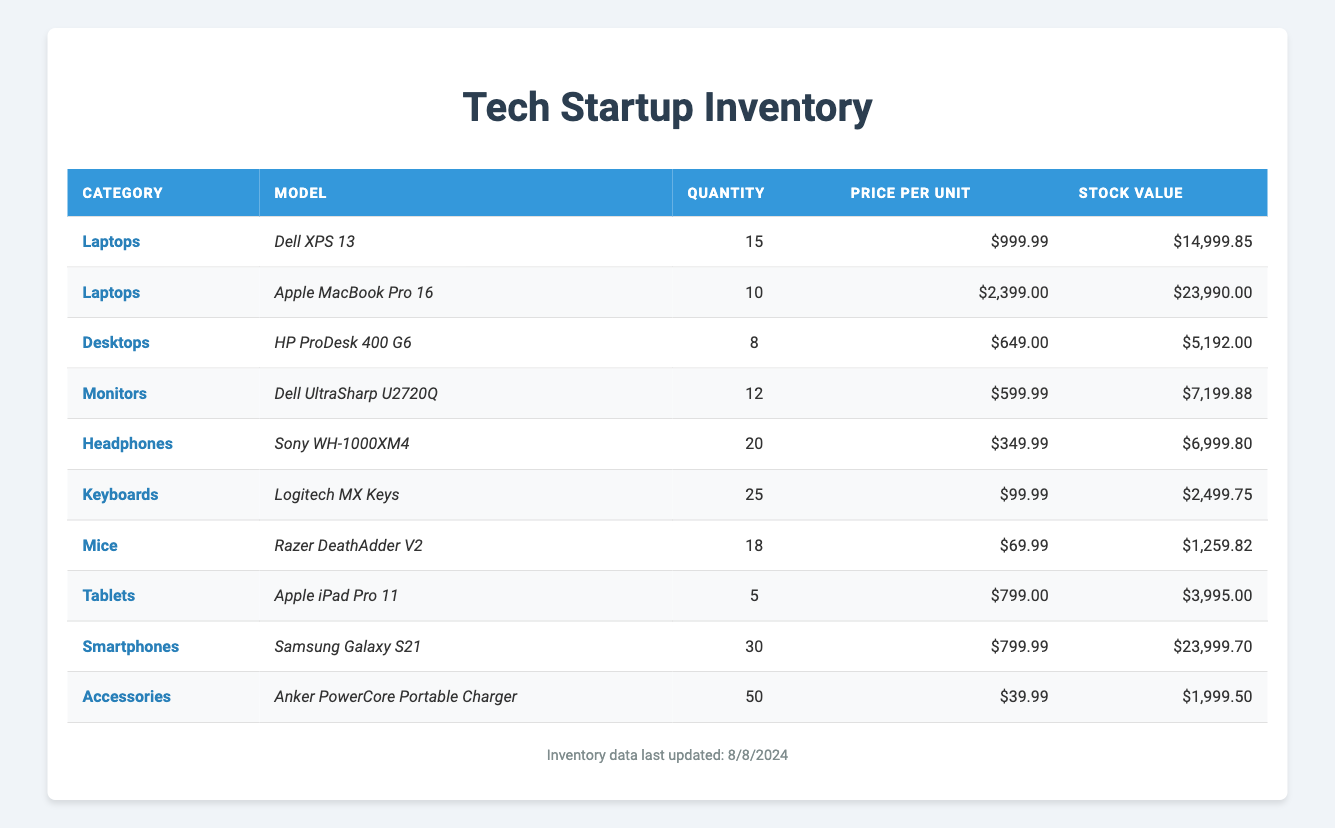What is the total quantity of Laptops in stock? The inventory lists two models of Laptops: Dell XPS 13 with a quantity of 15 and Apple MacBook Pro 16 with a quantity of 10. Adding these quantities together gives 15 + 10 = 25.
Answer: 25 Which model has the highest stock value? The stock values for each model are: Dell XPS 13 - 14999.85, Apple MacBook Pro 16 - 23990.00, HP ProDesk 400 G6 - 5192.00, Dell UltraSharp U2720Q - 7199.88, Sony WH-1000XM4 - 6999.80, Logitech MX Keys - 2499.75, Razer DeathAdder V2 - 1259.82, Apple iPad Pro 11 - 3995.00, Samsung Galaxy S21 - 23999.70, Anker PowerCore Portable Charger - 1999.50. The highest amount is 23990.00 for Apple MacBook Pro 16.
Answer: Apple MacBook Pro 16 Are there more Smartphones or Tablets in stock? The inventory shows 30 Smartphones (Samsung Galaxy S21) and 5 Tablets (Apple iPad Pro 11). Since 30 is greater than 5, there are more Smartphones in stock than Tablets.
Answer: Yes What is the average price per unit of all devices in the inventory? The total prices per unit are: 999.99 (Dell XPS 13), 2399.00 (Apple MacBook Pro 16), 649.00 (HP ProDesk 400 G6), 599.99 (Dell UltraSharp U2720Q), 349.99 (Sony WH-1000XM4), 99.99 (Logitech MX Keys), 69.99 (Razer DeathAdder V2), 799.00 (Apple iPad Pro 11), 799.99 (Samsung Galaxy S21), 39.99 (Anker PowerCore Portable Charger). Summing these gives a total of 999.99 + 2399.00 + 649.00 + 599.99 + 349.99 + 99.99 + 69.99 + 799.00 + 799.99 + 39.99 = 7,237.93. There are 10 models, so the average price per unit is 7237.93 / 10 = 723.79.
Answer: 723.79 What is the total stock value of Headphones and Keyboards combined? The stock values are: Headphones (Sony WH-1000XM4) = 6999.80 and Keyboards (Logitech MX Keys) = 2499.75. Adding these values gives 6999.80 + 2499.75 = 9499.55.
Answer: 9499.55 